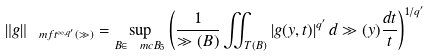<formula> <loc_0><loc_0><loc_500><loc_500>\| g \| _ { \ m f { t } ^ { \infty , { q ^ { \prime } } } ( \gg ) } = \sup _ { B \in \ m c { B } _ { 5 } } \left ( \frac { 1 } { \gg ( B ) } \iint _ { T ( B ) } | g ( y , t ) | ^ { q ^ { \prime } } \, d \gg ( y ) \frac { d t } { t } \right ) ^ { 1 / { q ^ { \prime } } }</formula> 